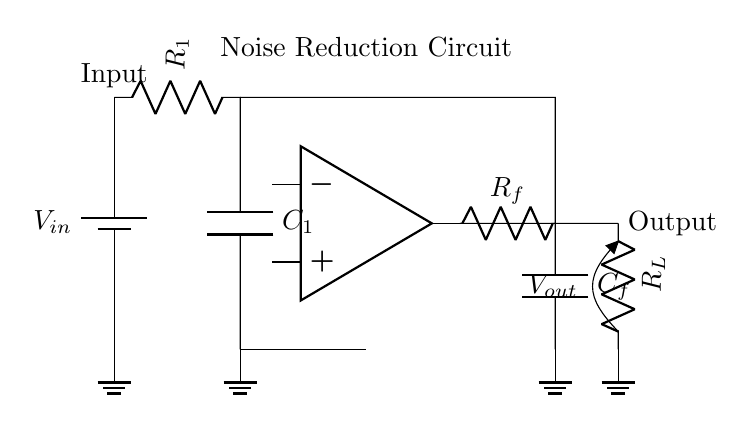What type of circuit is depicted here? The circuit represents a noise reduction circuit. This can be inferred from the label on the output node which indicates it is designed for reducing noise in audio signals.
Answer: Noise reduction circuit What is the purpose of the operational amplifier in this circuit? The operational amplifier is used for amplifying the signal while reducing noise. It takes the input signal and processes it to enhance the desired audio quality, acting essentially as the heart of the noise reduction method.
Answer: Amplification What is the function of the resistor R1? Resistor R1 forms part of the low-pass filter together with capacitor C1. This filter allows low frequencies to pass while attenuating high frequencies, effectively reducing noise.
Answer: Low-pass filter Which component determines the feedback in the circuit? The feedback in the circuit is determined by the resistor Rf connected between the output of the operational amplifier and the input. This configuration helps in stabilizing the gain and controlling the signal flow.
Answer: Resistor Rf What is the typical use of this type of circuit? This type of circuit is typically used in audio equipment to minimize unwanted noise during recording or playback, ensuring a clearer sound output.
Answer: Audio equipment What kind of loads can be connected to the output of this circuit? The output can connect to resistive loads, as indicated by the presence of resistor Rl, which indicates the load that the circuit can drive without distortion affecting the quality of the output signal.
Answer: Resistive loads 